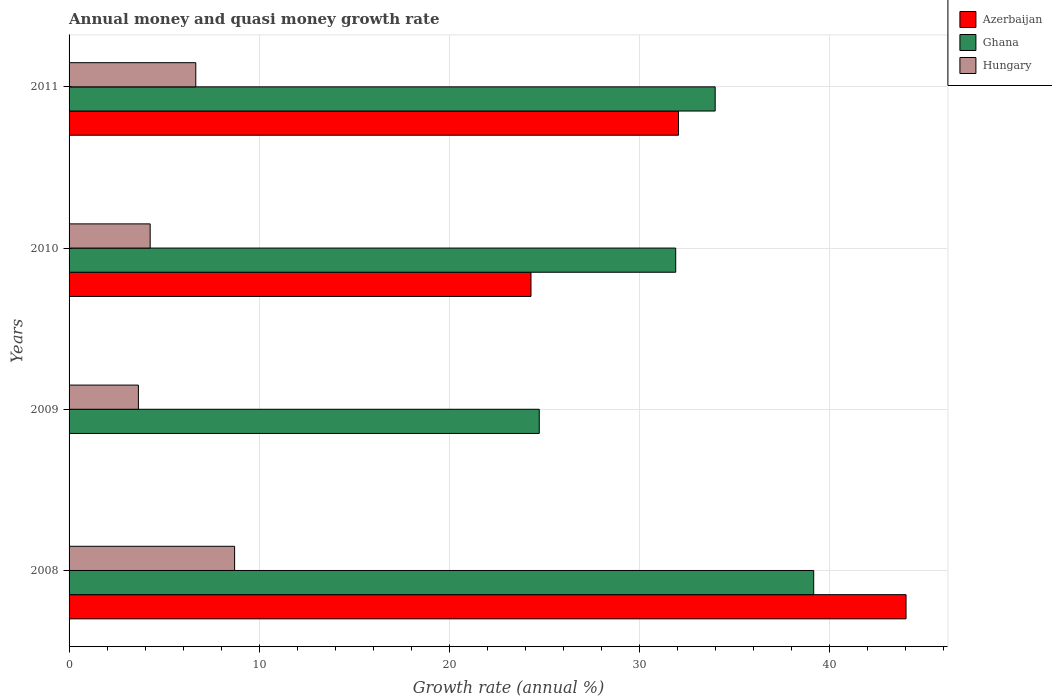How many groups of bars are there?
Provide a short and direct response. 4. Are the number of bars on each tick of the Y-axis equal?
Ensure brevity in your answer.  No. How many bars are there on the 4th tick from the bottom?
Give a very brief answer. 3. What is the label of the 4th group of bars from the top?
Give a very brief answer. 2008. In how many cases, is the number of bars for a given year not equal to the number of legend labels?
Provide a succinct answer. 1. What is the growth rate in Ghana in 2011?
Ensure brevity in your answer.  33.99. Across all years, what is the maximum growth rate in Hungary?
Provide a short and direct response. 8.71. Across all years, what is the minimum growth rate in Hungary?
Offer a very short reply. 3.65. In which year was the growth rate in Azerbaijan maximum?
Offer a terse response. 2008. What is the total growth rate in Ghana in the graph?
Your response must be concise. 129.83. What is the difference between the growth rate in Azerbaijan in 2010 and that in 2011?
Your response must be concise. -7.76. What is the difference between the growth rate in Ghana in 2010 and the growth rate in Azerbaijan in 2011?
Provide a short and direct response. -0.15. What is the average growth rate in Azerbaijan per year?
Offer a very short reply. 25.1. In the year 2008, what is the difference between the growth rate in Ghana and growth rate in Azerbaijan?
Provide a succinct answer. -4.86. What is the ratio of the growth rate in Azerbaijan in 2010 to that in 2011?
Make the answer very short. 0.76. Is the difference between the growth rate in Ghana in 2010 and 2011 greater than the difference between the growth rate in Azerbaijan in 2010 and 2011?
Provide a succinct answer. Yes. What is the difference between the highest and the second highest growth rate in Hungary?
Your answer should be compact. 2.04. What is the difference between the highest and the lowest growth rate in Azerbaijan?
Ensure brevity in your answer.  44.04. In how many years, is the growth rate in Azerbaijan greater than the average growth rate in Azerbaijan taken over all years?
Make the answer very short. 2. Are all the bars in the graph horizontal?
Your answer should be very brief. Yes. How many years are there in the graph?
Make the answer very short. 4. What is the difference between two consecutive major ticks on the X-axis?
Ensure brevity in your answer.  10. Does the graph contain grids?
Make the answer very short. Yes. What is the title of the graph?
Your response must be concise. Annual money and quasi money growth rate. What is the label or title of the X-axis?
Make the answer very short. Growth rate (annual %). What is the label or title of the Y-axis?
Keep it short and to the point. Years. What is the Growth rate (annual %) of Azerbaijan in 2008?
Ensure brevity in your answer.  44.04. What is the Growth rate (annual %) in Ghana in 2008?
Ensure brevity in your answer.  39.18. What is the Growth rate (annual %) in Hungary in 2008?
Offer a terse response. 8.71. What is the Growth rate (annual %) of Ghana in 2009?
Your answer should be compact. 24.74. What is the Growth rate (annual %) in Hungary in 2009?
Offer a very short reply. 3.65. What is the Growth rate (annual %) of Azerbaijan in 2010?
Provide a short and direct response. 24.3. What is the Growth rate (annual %) in Ghana in 2010?
Keep it short and to the point. 31.92. What is the Growth rate (annual %) of Hungary in 2010?
Offer a very short reply. 4.27. What is the Growth rate (annual %) in Azerbaijan in 2011?
Provide a succinct answer. 32.07. What is the Growth rate (annual %) of Ghana in 2011?
Give a very brief answer. 33.99. What is the Growth rate (annual %) of Hungary in 2011?
Your response must be concise. 6.67. Across all years, what is the maximum Growth rate (annual %) of Azerbaijan?
Offer a terse response. 44.04. Across all years, what is the maximum Growth rate (annual %) in Ghana?
Keep it short and to the point. 39.18. Across all years, what is the maximum Growth rate (annual %) of Hungary?
Offer a terse response. 8.71. Across all years, what is the minimum Growth rate (annual %) in Azerbaijan?
Ensure brevity in your answer.  0. Across all years, what is the minimum Growth rate (annual %) of Ghana?
Your response must be concise. 24.74. Across all years, what is the minimum Growth rate (annual %) of Hungary?
Your answer should be compact. 3.65. What is the total Growth rate (annual %) of Azerbaijan in the graph?
Keep it short and to the point. 100.41. What is the total Growth rate (annual %) of Ghana in the graph?
Offer a terse response. 129.83. What is the total Growth rate (annual %) in Hungary in the graph?
Provide a short and direct response. 23.29. What is the difference between the Growth rate (annual %) of Ghana in 2008 and that in 2009?
Make the answer very short. 14.44. What is the difference between the Growth rate (annual %) in Hungary in 2008 and that in 2009?
Your response must be concise. 5.06. What is the difference between the Growth rate (annual %) of Azerbaijan in 2008 and that in 2010?
Your response must be concise. 19.73. What is the difference between the Growth rate (annual %) in Ghana in 2008 and that in 2010?
Make the answer very short. 7.26. What is the difference between the Growth rate (annual %) in Hungary in 2008 and that in 2010?
Give a very brief answer. 4.44. What is the difference between the Growth rate (annual %) of Azerbaijan in 2008 and that in 2011?
Make the answer very short. 11.97. What is the difference between the Growth rate (annual %) of Ghana in 2008 and that in 2011?
Your answer should be very brief. 5.18. What is the difference between the Growth rate (annual %) of Hungary in 2008 and that in 2011?
Provide a succinct answer. 2.04. What is the difference between the Growth rate (annual %) in Ghana in 2009 and that in 2010?
Provide a short and direct response. -7.18. What is the difference between the Growth rate (annual %) in Hungary in 2009 and that in 2010?
Provide a succinct answer. -0.62. What is the difference between the Growth rate (annual %) in Ghana in 2009 and that in 2011?
Make the answer very short. -9.26. What is the difference between the Growth rate (annual %) in Hungary in 2009 and that in 2011?
Your answer should be compact. -3.02. What is the difference between the Growth rate (annual %) in Azerbaijan in 2010 and that in 2011?
Your response must be concise. -7.76. What is the difference between the Growth rate (annual %) of Ghana in 2010 and that in 2011?
Your response must be concise. -2.08. What is the difference between the Growth rate (annual %) of Hungary in 2010 and that in 2011?
Keep it short and to the point. -2.4. What is the difference between the Growth rate (annual %) of Azerbaijan in 2008 and the Growth rate (annual %) of Ghana in 2009?
Keep it short and to the point. 19.3. What is the difference between the Growth rate (annual %) of Azerbaijan in 2008 and the Growth rate (annual %) of Hungary in 2009?
Offer a terse response. 40.39. What is the difference between the Growth rate (annual %) in Ghana in 2008 and the Growth rate (annual %) in Hungary in 2009?
Offer a terse response. 35.53. What is the difference between the Growth rate (annual %) in Azerbaijan in 2008 and the Growth rate (annual %) in Ghana in 2010?
Your answer should be compact. 12.12. What is the difference between the Growth rate (annual %) in Azerbaijan in 2008 and the Growth rate (annual %) in Hungary in 2010?
Offer a very short reply. 39.77. What is the difference between the Growth rate (annual %) in Ghana in 2008 and the Growth rate (annual %) in Hungary in 2010?
Offer a terse response. 34.91. What is the difference between the Growth rate (annual %) of Azerbaijan in 2008 and the Growth rate (annual %) of Ghana in 2011?
Make the answer very short. 10.04. What is the difference between the Growth rate (annual %) in Azerbaijan in 2008 and the Growth rate (annual %) in Hungary in 2011?
Provide a short and direct response. 37.37. What is the difference between the Growth rate (annual %) of Ghana in 2008 and the Growth rate (annual %) of Hungary in 2011?
Offer a terse response. 32.51. What is the difference between the Growth rate (annual %) in Ghana in 2009 and the Growth rate (annual %) in Hungary in 2010?
Give a very brief answer. 20.47. What is the difference between the Growth rate (annual %) in Ghana in 2009 and the Growth rate (annual %) in Hungary in 2011?
Provide a succinct answer. 18.07. What is the difference between the Growth rate (annual %) in Azerbaijan in 2010 and the Growth rate (annual %) in Ghana in 2011?
Your answer should be compact. -9.69. What is the difference between the Growth rate (annual %) in Azerbaijan in 2010 and the Growth rate (annual %) in Hungary in 2011?
Make the answer very short. 17.64. What is the difference between the Growth rate (annual %) of Ghana in 2010 and the Growth rate (annual %) of Hungary in 2011?
Ensure brevity in your answer.  25.25. What is the average Growth rate (annual %) of Azerbaijan per year?
Keep it short and to the point. 25.1. What is the average Growth rate (annual %) of Ghana per year?
Provide a short and direct response. 32.46. What is the average Growth rate (annual %) in Hungary per year?
Offer a very short reply. 5.82. In the year 2008, what is the difference between the Growth rate (annual %) of Azerbaijan and Growth rate (annual %) of Ghana?
Keep it short and to the point. 4.86. In the year 2008, what is the difference between the Growth rate (annual %) in Azerbaijan and Growth rate (annual %) in Hungary?
Make the answer very short. 35.33. In the year 2008, what is the difference between the Growth rate (annual %) in Ghana and Growth rate (annual %) in Hungary?
Give a very brief answer. 30.47. In the year 2009, what is the difference between the Growth rate (annual %) of Ghana and Growth rate (annual %) of Hungary?
Your answer should be compact. 21.09. In the year 2010, what is the difference between the Growth rate (annual %) in Azerbaijan and Growth rate (annual %) in Ghana?
Your answer should be very brief. -7.61. In the year 2010, what is the difference between the Growth rate (annual %) of Azerbaijan and Growth rate (annual %) of Hungary?
Provide a succinct answer. 20.04. In the year 2010, what is the difference between the Growth rate (annual %) of Ghana and Growth rate (annual %) of Hungary?
Offer a very short reply. 27.65. In the year 2011, what is the difference between the Growth rate (annual %) in Azerbaijan and Growth rate (annual %) in Ghana?
Provide a short and direct response. -1.93. In the year 2011, what is the difference between the Growth rate (annual %) in Azerbaijan and Growth rate (annual %) in Hungary?
Provide a succinct answer. 25.4. In the year 2011, what is the difference between the Growth rate (annual %) in Ghana and Growth rate (annual %) in Hungary?
Make the answer very short. 27.33. What is the ratio of the Growth rate (annual %) in Ghana in 2008 to that in 2009?
Provide a short and direct response. 1.58. What is the ratio of the Growth rate (annual %) of Hungary in 2008 to that in 2009?
Your answer should be compact. 2.39. What is the ratio of the Growth rate (annual %) in Azerbaijan in 2008 to that in 2010?
Your answer should be compact. 1.81. What is the ratio of the Growth rate (annual %) in Ghana in 2008 to that in 2010?
Make the answer very short. 1.23. What is the ratio of the Growth rate (annual %) in Hungary in 2008 to that in 2010?
Offer a very short reply. 2.04. What is the ratio of the Growth rate (annual %) of Azerbaijan in 2008 to that in 2011?
Give a very brief answer. 1.37. What is the ratio of the Growth rate (annual %) of Ghana in 2008 to that in 2011?
Your answer should be compact. 1.15. What is the ratio of the Growth rate (annual %) of Hungary in 2008 to that in 2011?
Offer a terse response. 1.31. What is the ratio of the Growth rate (annual %) in Ghana in 2009 to that in 2010?
Provide a succinct answer. 0.78. What is the ratio of the Growth rate (annual %) in Hungary in 2009 to that in 2010?
Ensure brevity in your answer.  0.85. What is the ratio of the Growth rate (annual %) in Ghana in 2009 to that in 2011?
Offer a terse response. 0.73. What is the ratio of the Growth rate (annual %) in Hungary in 2009 to that in 2011?
Provide a succinct answer. 0.55. What is the ratio of the Growth rate (annual %) in Azerbaijan in 2010 to that in 2011?
Offer a terse response. 0.76. What is the ratio of the Growth rate (annual %) of Ghana in 2010 to that in 2011?
Offer a very short reply. 0.94. What is the ratio of the Growth rate (annual %) in Hungary in 2010 to that in 2011?
Your response must be concise. 0.64. What is the difference between the highest and the second highest Growth rate (annual %) of Azerbaijan?
Provide a succinct answer. 11.97. What is the difference between the highest and the second highest Growth rate (annual %) in Ghana?
Make the answer very short. 5.18. What is the difference between the highest and the second highest Growth rate (annual %) in Hungary?
Your response must be concise. 2.04. What is the difference between the highest and the lowest Growth rate (annual %) in Azerbaijan?
Offer a very short reply. 44.04. What is the difference between the highest and the lowest Growth rate (annual %) in Ghana?
Provide a succinct answer. 14.44. What is the difference between the highest and the lowest Growth rate (annual %) in Hungary?
Your response must be concise. 5.06. 